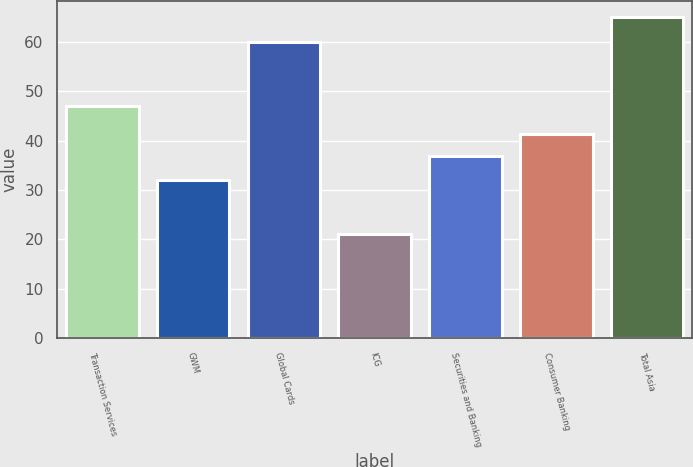Convert chart to OTSL. <chart><loc_0><loc_0><loc_500><loc_500><bar_chart><fcel>Transaction Services<fcel>GWM<fcel>Global Cards<fcel>ICG<fcel>Securities and Banking<fcel>Consumer Banking<fcel>Total Asia<nl><fcel>47<fcel>32<fcel>60<fcel>21<fcel>37<fcel>41.4<fcel>65<nl></chart> 